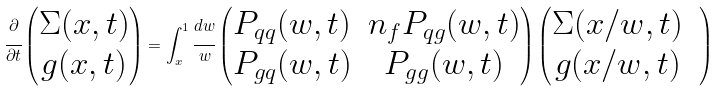Convert formula to latex. <formula><loc_0><loc_0><loc_500><loc_500>\cfrac { \partial } { \partial t } \begin{pmatrix} \Sigma ( x , t ) \\ g ( x , t ) \end{pmatrix} = \int _ { x } ^ { 1 } \cfrac { d w } { w } \begin{pmatrix} P _ { q q } ( w , t ) & n _ { f } P _ { q g } ( w , t ) \\ P _ { g q } ( w , t ) & P _ { g g } ( w , t ) \\ \end{pmatrix} \begin{pmatrix} \Sigma ( x / w , t ) & \\ g ( x / w , t ) & \end{pmatrix}</formula> 